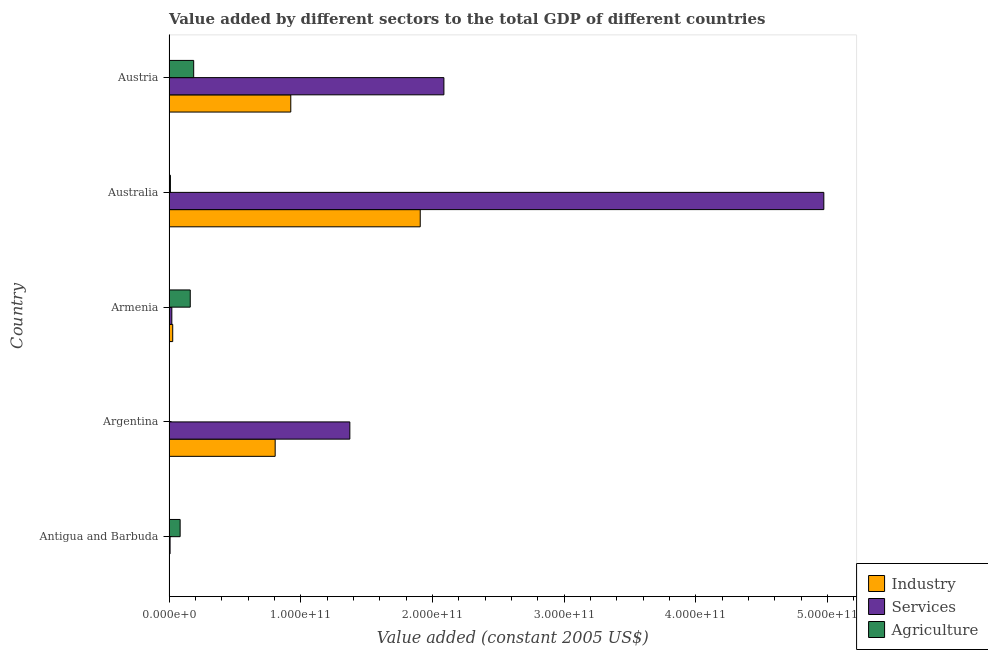How many groups of bars are there?
Your answer should be compact. 5. Are the number of bars per tick equal to the number of legend labels?
Your answer should be compact. Yes. Are the number of bars on each tick of the Y-axis equal?
Give a very brief answer. Yes. How many bars are there on the 4th tick from the bottom?
Make the answer very short. 3. What is the label of the 3rd group of bars from the top?
Your answer should be compact. Armenia. What is the value added by services in Antigua and Barbuda?
Offer a very short reply. 8.23e+08. Across all countries, what is the maximum value added by industrial sector?
Provide a succinct answer. 1.91e+11. Across all countries, what is the minimum value added by industrial sector?
Offer a terse response. 2.18e+08. In which country was the value added by services minimum?
Provide a succinct answer. Antigua and Barbuda. What is the total value added by services in the graph?
Keep it short and to the point. 8.46e+11. What is the difference between the value added by industrial sector in Argentina and that in Australia?
Keep it short and to the point. -1.10e+11. What is the difference between the value added by industrial sector in Antigua and Barbuda and the value added by agricultural sector in Armenia?
Ensure brevity in your answer.  -1.59e+1. What is the average value added by services per country?
Provide a succinct answer. 1.69e+11. What is the difference between the value added by agricultural sector and value added by services in Australia?
Give a very brief answer. -4.96e+11. What is the ratio of the value added by services in Australia to that in Austria?
Offer a very short reply. 2.38. Is the difference between the value added by industrial sector in Armenia and Australia greater than the difference between the value added by agricultural sector in Armenia and Australia?
Your response must be concise. No. What is the difference between the highest and the second highest value added by agricultural sector?
Your response must be concise. 2.61e+09. What is the difference between the highest and the lowest value added by agricultural sector?
Give a very brief answer. 1.87e+1. In how many countries, is the value added by agricultural sector greater than the average value added by agricultural sector taken over all countries?
Provide a short and direct response. 2. What does the 1st bar from the top in Australia represents?
Make the answer very short. Agriculture. What does the 3rd bar from the bottom in Antigua and Barbuda represents?
Offer a very short reply. Agriculture. How many countries are there in the graph?
Your answer should be compact. 5. What is the difference between two consecutive major ticks on the X-axis?
Make the answer very short. 1.00e+11. Where does the legend appear in the graph?
Your response must be concise. Bottom right. How many legend labels are there?
Give a very brief answer. 3. What is the title of the graph?
Offer a very short reply. Value added by different sectors to the total GDP of different countries. Does "Transport equipments" appear as one of the legend labels in the graph?
Your answer should be very brief. No. What is the label or title of the X-axis?
Your answer should be compact. Value added (constant 2005 US$). What is the label or title of the Y-axis?
Your answer should be very brief. Country. What is the Value added (constant 2005 US$) of Industry in Antigua and Barbuda?
Your answer should be very brief. 2.18e+08. What is the Value added (constant 2005 US$) in Services in Antigua and Barbuda?
Your response must be concise. 8.23e+08. What is the Value added (constant 2005 US$) in Agriculture in Antigua and Barbuda?
Give a very brief answer. 8.46e+09. What is the Value added (constant 2005 US$) in Industry in Argentina?
Provide a succinct answer. 8.06e+1. What is the Value added (constant 2005 US$) of Services in Argentina?
Your response must be concise. 1.37e+11. What is the Value added (constant 2005 US$) of Agriculture in Argentina?
Ensure brevity in your answer.  1.75e+07. What is the Value added (constant 2005 US$) in Industry in Armenia?
Give a very brief answer. 2.83e+09. What is the Value added (constant 2005 US$) of Services in Armenia?
Your answer should be compact. 2.15e+09. What is the Value added (constant 2005 US$) of Agriculture in Armenia?
Offer a very short reply. 1.61e+1. What is the Value added (constant 2005 US$) of Industry in Australia?
Provide a short and direct response. 1.91e+11. What is the Value added (constant 2005 US$) in Services in Australia?
Your response must be concise. 4.97e+11. What is the Value added (constant 2005 US$) of Agriculture in Australia?
Your response must be concise. 1.07e+09. What is the Value added (constant 2005 US$) in Industry in Austria?
Ensure brevity in your answer.  9.25e+1. What is the Value added (constant 2005 US$) of Services in Austria?
Your answer should be compact. 2.09e+11. What is the Value added (constant 2005 US$) in Agriculture in Austria?
Make the answer very short. 1.87e+1. Across all countries, what is the maximum Value added (constant 2005 US$) in Industry?
Ensure brevity in your answer.  1.91e+11. Across all countries, what is the maximum Value added (constant 2005 US$) of Services?
Offer a very short reply. 4.97e+11. Across all countries, what is the maximum Value added (constant 2005 US$) in Agriculture?
Your answer should be compact. 1.87e+1. Across all countries, what is the minimum Value added (constant 2005 US$) in Industry?
Offer a very short reply. 2.18e+08. Across all countries, what is the minimum Value added (constant 2005 US$) in Services?
Provide a succinct answer. 8.23e+08. Across all countries, what is the minimum Value added (constant 2005 US$) of Agriculture?
Your answer should be very brief. 1.75e+07. What is the total Value added (constant 2005 US$) in Industry in the graph?
Provide a short and direct response. 3.67e+11. What is the total Value added (constant 2005 US$) of Services in the graph?
Provide a succinct answer. 8.46e+11. What is the total Value added (constant 2005 US$) of Agriculture in the graph?
Keep it short and to the point. 4.44e+1. What is the difference between the Value added (constant 2005 US$) of Industry in Antigua and Barbuda and that in Argentina?
Your answer should be very brief. -8.04e+1. What is the difference between the Value added (constant 2005 US$) of Services in Antigua and Barbuda and that in Argentina?
Offer a terse response. -1.36e+11. What is the difference between the Value added (constant 2005 US$) of Agriculture in Antigua and Barbuda and that in Argentina?
Your answer should be compact. 8.44e+09. What is the difference between the Value added (constant 2005 US$) of Industry in Antigua and Barbuda and that in Armenia?
Offer a terse response. -2.61e+09. What is the difference between the Value added (constant 2005 US$) of Services in Antigua and Barbuda and that in Armenia?
Keep it short and to the point. -1.33e+09. What is the difference between the Value added (constant 2005 US$) in Agriculture in Antigua and Barbuda and that in Armenia?
Offer a very short reply. -7.68e+09. What is the difference between the Value added (constant 2005 US$) in Industry in Antigua and Barbuda and that in Australia?
Offer a very short reply. -1.91e+11. What is the difference between the Value added (constant 2005 US$) in Services in Antigua and Barbuda and that in Australia?
Make the answer very short. -4.96e+11. What is the difference between the Value added (constant 2005 US$) in Agriculture in Antigua and Barbuda and that in Australia?
Your answer should be very brief. 7.39e+09. What is the difference between the Value added (constant 2005 US$) of Industry in Antigua and Barbuda and that in Austria?
Offer a very short reply. -9.23e+1. What is the difference between the Value added (constant 2005 US$) of Services in Antigua and Barbuda and that in Austria?
Offer a terse response. -2.08e+11. What is the difference between the Value added (constant 2005 US$) in Agriculture in Antigua and Barbuda and that in Austria?
Make the answer very short. -1.03e+1. What is the difference between the Value added (constant 2005 US$) in Industry in Argentina and that in Armenia?
Your answer should be compact. 7.78e+1. What is the difference between the Value added (constant 2005 US$) in Services in Argentina and that in Armenia?
Your answer should be compact. 1.35e+11. What is the difference between the Value added (constant 2005 US$) of Agriculture in Argentina and that in Armenia?
Your answer should be compact. -1.61e+1. What is the difference between the Value added (constant 2005 US$) in Industry in Argentina and that in Australia?
Offer a very short reply. -1.10e+11. What is the difference between the Value added (constant 2005 US$) in Services in Argentina and that in Australia?
Ensure brevity in your answer.  -3.60e+11. What is the difference between the Value added (constant 2005 US$) of Agriculture in Argentina and that in Australia?
Offer a terse response. -1.05e+09. What is the difference between the Value added (constant 2005 US$) of Industry in Argentina and that in Austria?
Provide a succinct answer. -1.19e+1. What is the difference between the Value added (constant 2005 US$) of Services in Argentina and that in Austria?
Make the answer very short. -7.14e+1. What is the difference between the Value added (constant 2005 US$) in Agriculture in Argentina and that in Austria?
Your response must be concise. -1.87e+1. What is the difference between the Value added (constant 2005 US$) in Industry in Armenia and that in Australia?
Make the answer very short. -1.88e+11. What is the difference between the Value added (constant 2005 US$) in Services in Armenia and that in Australia?
Provide a short and direct response. -4.95e+11. What is the difference between the Value added (constant 2005 US$) in Agriculture in Armenia and that in Australia?
Ensure brevity in your answer.  1.51e+1. What is the difference between the Value added (constant 2005 US$) of Industry in Armenia and that in Austria?
Your response must be concise. -8.96e+1. What is the difference between the Value added (constant 2005 US$) of Services in Armenia and that in Austria?
Keep it short and to the point. -2.07e+11. What is the difference between the Value added (constant 2005 US$) in Agriculture in Armenia and that in Austria?
Provide a short and direct response. -2.61e+09. What is the difference between the Value added (constant 2005 US$) of Industry in Australia and that in Austria?
Make the answer very short. 9.83e+1. What is the difference between the Value added (constant 2005 US$) in Services in Australia and that in Austria?
Keep it short and to the point. 2.88e+11. What is the difference between the Value added (constant 2005 US$) of Agriculture in Australia and that in Austria?
Provide a short and direct response. -1.77e+1. What is the difference between the Value added (constant 2005 US$) in Industry in Antigua and Barbuda and the Value added (constant 2005 US$) in Services in Argentina?
Provide a succinct answer. -1.37e+11. What is the difference between the Value added (constant 2005 US$) of Industry in Antigua and Barbuda and the Value added (constant 2005 US$) of Agriculture in Argentina?
Provide a short and direct response. 2.01e+08. What is the difference between the Value added (constant 2005 US$) of Services in Antigua and Barbuda and the Value added (constant 2005 US$) of Agriculture in Argentina?
Ensure brevity in your answer.  8.06e+08. What is the difference between the Value added (constant 2005 US$) of Industry in Antigua and Barbuda and the Value added (constant 2005 US$) of Services in Armenia?
Offer a terse response. -1.94e+09. What is the difference between the Value added (constant 2005 US$) of Industry in Antigua and Barbuda and the Value added (constant 2005 US$) of Agriculture in Armenia?
Provide a short and direct response. -1.59e+1. What is the difference between the Value added (constant 2005 US$) in Services in Antigua and Barbuda and the Value added (constant 2005 US$) in Agriculture in Armenia?
Give a very brief answer. -1.53e+1. What is the difference between the Value added (constant 2005 US$) of Industry in Antigua and Barbuda and the Value added (constant 2005 US$) of Services in Australia?
Give a very brief answer. -4.97e+11. What is the difference between the Value added (constant 2005 US$) in Industry in Antigua and Barbuda and the Value added (constant 2005 US$) in Agriculture in Australia?
Your response must be concise. -8.50e+08. What is the difference between the Value added (constant 2005 US$) of Services in Antigua and Barbuda and the Value added (constant 2005 US$) of Agriculture in Australia?
Your answer should be compact. -2.45e+08. What is the difference between the Value added (constant 2005 US$) of Industry in Antigua and Barbuda and the Value added (constant 2005 US$) of Services in Austria?
Give a very brief answer. -2.09e+11. What is the difference between the Value added (constant 2005 US$) of Industry in Antigua and Barbuda and the Value added (constant 2005 US$) of Agriculture in Austria?
Your answer should be very brief. -1.85e+1. What is the difference between the Value added (constant 2005 US$) in Services in Antigua and Barbuda and the Value added (constant 2005 US$) in Agriculture in Austria?
Keep it short and to the point. -1.79e+1. What is the difference between the Value added (constant 2005 US$) in Industry in Argentina and the Value added (constant 2005 US$) in Services in Armenia?
Your response must be concise. 7.85e+1. What is the difference between the Value added (constant 2005 US$) of Industry in Argentina and the Value added (constant 2005 US$) of Agriculture in Armenia?
Ensure brevity in your answer.  6.45e+1. What is the difference between the Value added (constant 2005 US$) of Services in Argentina and the Value added (constant 2005 US$) of Agriculture in Armenia?
Your answer should be compact. 1.21e+11. What is the difference between the Value added (constant 2005 US$) of Industry in Argentina and the Value added (constant 2005 US$) of Services in Australia?
Keep it short and to the point. -4.17e+11. What is the difference between the Value added (constant 2005 US$) of Industry in Argentina and the Value added (constant 2005 US$) of Agriculture in Australia?
Provide a short and direct response. 7.95e+1. What is the difference between the Value added (constant 2005 US$) of Services in Argentina and the Value added (constant 2005 US$) of Agriculture in Australia?
Give a very brief answer. 1.36e+11. What is the difference between the Value added (constant 2005 US$) in Industry in Argentina and the Value added (constant 2005 US$) in Services in Austria?
Your response must be concise. -1.28e+11. What is the difference between the Value added (constant 2005 US$) in Industry in Argentina and the Value added (constant 2005 US$) in Agriculture in Austria?
Your answer should be very brief. 6.19e+1. What is the difference between the Value added (constant 2005 US$) of Services in Argentina and the Value added (constant 2005 US$) of Agriculture in Austria?
Offer a terse response. 1.19e+11. What is the difference between the Value added (constant 2005 US$) in Industry in Armenia and the Value added (constant 2005 US$) in Services in Australia?
Keep it short and to the point. -4.94e+11. What is the difference between the Value added (constant 2005 US$) of Industry in Armenia and the Value added (constant 2005 US$) of Agriculture in Australia?
Your answer should be compact. 1.76e+09. What is the difference between the Value added (constant 2005 US$) in Services in Armenia and the Value added (constant 2005 US$) in Agriculture in Australia?
Keep it short and to the point. 1.09e+09. What is the difference between the Value added (constant 2005 US$) of Industry in Armenia and the Value added (constant 2005 US$) of Services in Austria?
Keep it short and to the point. -2.06e+11. What is the difference between the Value added (constant 2005 US$) of Industry in Armenia and the Value added (constant 2005 US$) of Agriculture in Austria?
Provide a short and direct response. -1.59e+1. What is the difference between the Value added (constant 2005 US$) of Services in Armenia and the Value added (constant 2005 US$) of Agriculture in Austria?
Provide a short and direct response. -1.66e+1. What is the difference between the Value added (constant 2005 US$) of Industry in Australia and the Value added (constant 2005 US$) of Services in Austria?
Give a very brief answer. -1.80e+1. What is the difference between the Value added (constant 2005 US$) in Industry in Australia and the Value added (constant 2005 US$) in Agriculture in Austria?
Ensure brevity in your answer.  1.72e+11. What is the difference between the Value added (constant 2005 US$) in Services in Australia and the Value added (constant 2005 US$) in Agriculture in Austria?
Provide a succinct answer. 4.78e+11. What is the average Value added (constant 2005 US$) in Industry per country?
Offer a terse response. 7.34e+1. What is the average Value added (constant 2005 US$) of Services per country?
Provide a short and direct response. 1.69e+11. What is the average Value added (constant 2005 US$) of Agriculture per country?
Offer a terse response. 8.89e+09. What is the difference between the Value added (constant 2005 US$) of Industry and Value added (constant 2005 US$) of Services in Antigua and Barbuda?
Make the answer very short. -6.05e+08. What is the difference between the Value added (constant 2005 US$) in Industry and Value added (constant 2005 US$) in Agriculture in Antigua and Barbuda?
Your answer should be compact. -8.24e+09. What is the difference between the Value added (constant 2005 US$) of Services and Value added (constant 2005 US$) of Agriculture in Antigua and Barbuda?
Your answer should be compact. -7.64e+09. What is the difference between the Value added (constant 2005 US$) in Industry and Value added (constant 2005 US$) in Services in Argentina?
Give a very brief answer. -5.67e+1. What is the difference between the Value added (constant 2005 US$) of Industry and Value added (constant 2005 US$) of Agriculture in Argentina?
Your answer should be compact. 8.06e+1. What is the difference between the Value added (constant 2005 US$) of Services and Value added (constant 2005 US$) of Agriculture in Argentina?
Offer a very short reply. 1.37e+11. What is the difference between the Value added (constant 2005 US$) of Industry and Value added (constant 2005 US$) of Services in Armenia?
Make the answer very short. 6.73e+08. What is the difference between the Value added (constant 2005 US$) of Industry and Value added (constant 2005 US$) of Agriculture in Armenia?
Offer a terse response. -1.33e+1. What is the difference between the Value added (constant 2005 US$) of Services and Value added (constant 2005 US$) of Agriculture in Armenia?
Provide a short and direct response. -1.40e+1. What is the difference between the Value added (constant 2005 US$) in Industry and Value added (constant 2005 US$) in Services in Australia?
Provide a succinct answer. -3.06e+11. What is the difference between the Value added (constant 2005 US$) in Industry and Value added (constant 2005 US$) in Agriculture in Australia?
Provide a short and direct response. 1.90e+11. What is the difference between the Value added (constant 2005 US$) of Services and Value added (constant 2005 US$) of Agriculture in Australia?
Offer a very short reply. 4.96e+11. What is the difference between the Value added (constant 2005 US$) of Industry and Value added (constant 2005 US$) of Services in Austria?
Provide a succinct answer. -1.16e+11. What is the difference between the Value added (constant 2005 US$) in Industry and Value added (constant 2005 US$) in Agriculture in Austria?
Ensure brevity in your answer.  7.37e+1. What is the difference between the Value added (constant 2005 US$) in Services and Value added (constant 2005 US$) in Agriculture in Austria?
Ensure brevity in your answer.  1.90e+11. What is the ratio of the Value added (constant 2005 US$) in Industry in Antigua and Barbuda to that in Argentina?
Offer a very short reply. 0. What is the ratio of the Value added (constant 2005 US$) of Services in Antigua and Barbuda to that in Argentina?
Provide a succinct answer. 0.01. What is the ratio of the Value added (constant 2005 US$) in Agriculture in Antigua and Barbuda to that in Argentina?
Make the answer very short. 482.85. What is the ratio of the Value added (constant 2005 US$) of Industry in Antigua and Barbuda to that in Armenia?
Make the answer very short. 0.08. What is the ratio of the Value added (constant 2005 US$) in Services in Antigua and Barbuda to that in Armenia?
Make the answer very short. 0.38. What is the ratio of the Value added (constant 2005 US$) in Agriculture in Antigua and Barbuda to that in Armenia?
Give a very brief answer. 0.52. What is the ratio of the Value added (constant 2005 US$) in Industry in Antigua and Barbuda to that in Australia?
Offer a very short reply. 0. What is the ratio of the Value added (constant 2005 US$) in Services in Antigua and Barbuda to that in Australia?
Make the answer very short. 0. What is the ratio of the Value added (constant 2005 US$) of Agriculture in Antigua and Barbuda to that in Australia?
Make the answer very short. 7.92. What is the ratio of the Value added (constant 2005 US$) in Industry in Antigua and Barbuda to that in Austria?
Provide a succinct answer. 0. What is the ratio of the Value added (constant 2005 US$) of Services in Antigua and Barbuda to that in Austria?
Make the answer very short. 0. What is the ratio of the Value added (constant 2005 US$) of Agriculture in Antigua and Barbuda to that in Austria?
Your response must be concise. 0.45. What is the ratio of the Value added (constant 2005 US$) of Industry in Argentina to that in Armenia?
Offer a very short reply. 28.52. What is the ratio of the Value added (constant 2005 US$) in Services in Argentina to that in Armenia?
Provide a succinct answer. 63.76. What is the ratio of the Value added (constant 2005 US$) in Agriculture in Argentina to that in Armenia?
Your answer should be compact. 0. What is the ratio of the Value added (constant 2005 US$) of Industry in Argentina to that in Australia?
Your answer should be compact. 0.42. What is the ratio of the Value added (constant 2005 US$) of Services in Argentina to that in Australia?
Ensure brevity in your answer.  0.28. What is the ratio of the Value added (constant 2005 US$) of Agriculture in Argentina to that in Australia?
Provide a succinct answer. 0.02. What is the ratio of the Value added (constant 2005 US$) of Industry in Argentina to that in Austria?
Provide a succinct answer. 0.87. What is the ratio of the Value added (constant 2005 US$) in Services in Argentina to that in Austria?
Provide a succinct answer. 0.66. What is the ratio of the Value added (constant 2005 US$) of Agriculture in Argentina to that in Austria?
Your answer should be compact. 0. What is the ratio of the Value added (constant 2005 US$) of Industry in Armenia to that in Australia?
Make the answer very short. 0.01. What is the ratio of the Value added (constant 2005 US$) in Services in Armenia to that in Australia?
Ensure brevity in your answer.  0. What is the ratio of the Value added (constant 2005 US$) of Agriculture in Armenia to that in Australia?
Provide a short and direct response. 15.11. What is the ratio of the Value added (constant 2005 US$) in Industry in Armenia to that in Austria?
Give a very brief answer. 0.03. What is the ratio of the Value added (constant 2005 US$) of Services in Armenia to that in Austria?
Give a very brief answer. 0.01. What is the ratio of the Value added (constant 2005 US$) in Agriculture in Armenia to that in Austria?
Your answer should be compact. 0.86. What is the ratio of the Value added (constant 2005 US$) of Industry in Australia to that in Austria?
Offer a terse response. 2.06. What is the ratio of the Value added (constant 2005 US$) in Services in Australia to that in Austria?
Give a very brief answer. 2.38. What is the ratio of the Value added (constant 2005 US$) in Agriculture in Australia to that in Austria?
Offer a terse response. 0.06. What is the difference between the highest and the second highest Value added (constant 2005 US$) of Industry?
Give a very brief answer. 9.83e+1. What is the difference between the highest and the second highest Value added (constant 2005 US$) of Services?
Offer a terse response. 2.88e+11. What is the difference between the highest and the second highest Value added (constant 2005 US$) of Agriculture?
Provide a short and direct response. 2.61e+09. What is the difference between the highest and the lowest Value added (constant 2005 US$) in Industry?
Your answer should be compact. 1.91e+11. What is the difference between the highest and the lowest Value added (constant 2005 US$) in Services?
Provide a short and direct response. 4.96e+11. What is the difference between the highest and the lowest Value added (constant 2005 US$) of Agriculture?
Offer a very short reply. 1.87e+1. 